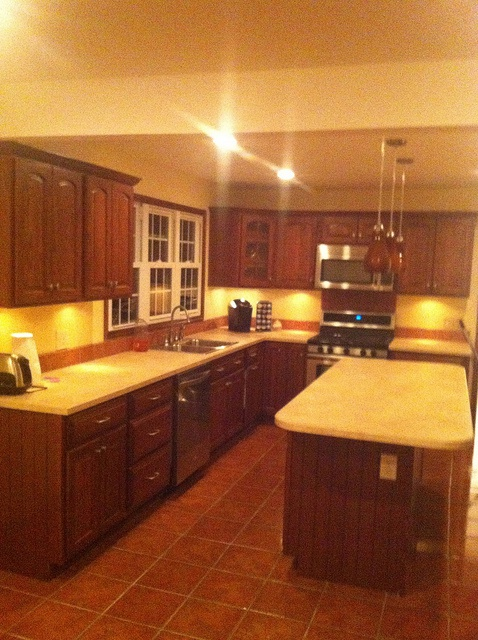Describe the objects in this image and their specific colors. I can see oven in lightyellow, maroon, brown, and gray tones, microwave in lightyellow, brown, maroon, and salmon tones, and sink in lightyellow, brown, salmon, tan, and maroon tones in this image. 